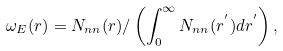Convert formula to latex. <formula><loc_0><loc_0><loc_500><loc_500>\omega _ { E } ( r ) = N _ { n n } ( r ) / \left ( \int _ { 0 } ^ { \infty } { N _ { n n } ( r ^ { ^ { \prime } } ) d r ^ { ^ { \prime } } } \right ) ,</formula> 